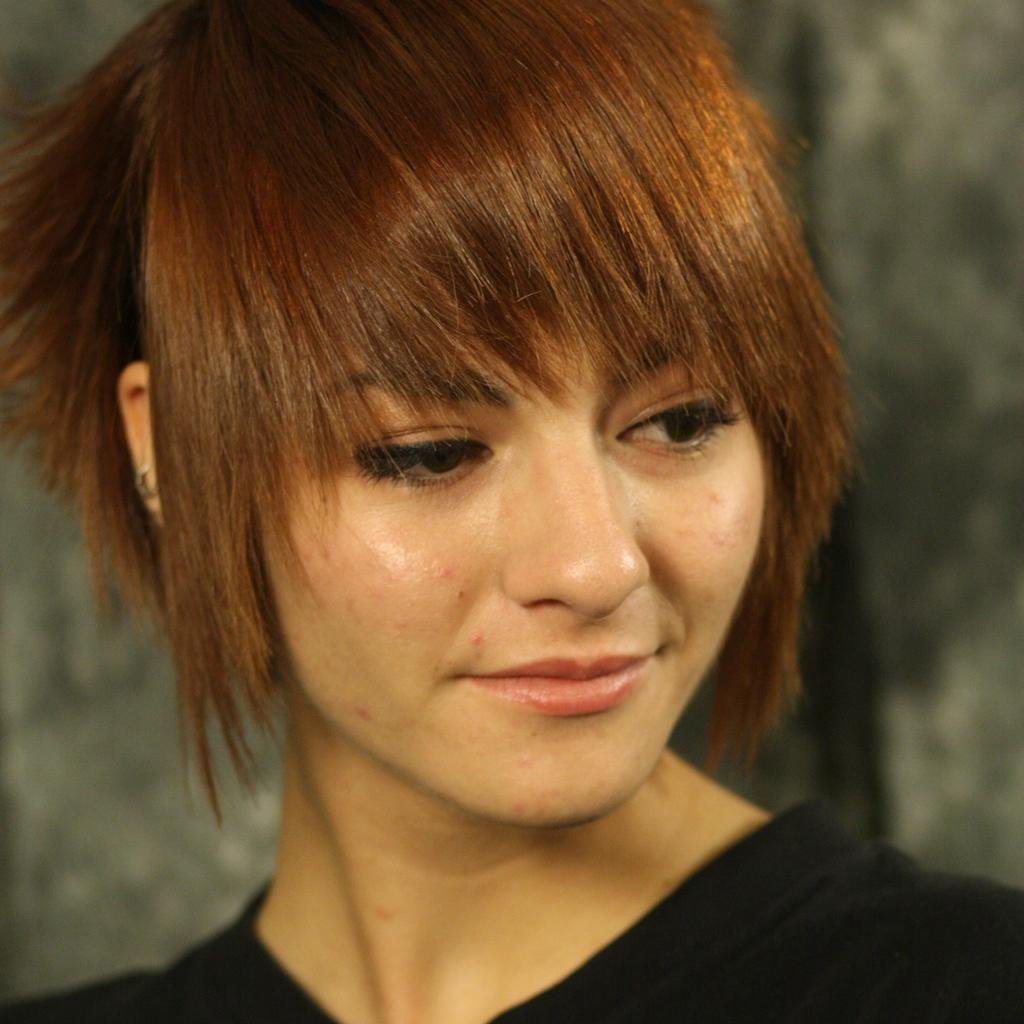Who is the main subject in the image? There is a woman in the image. Can you describe the background of the image? The background of the image is blurred. What type of punishment is the woman receiving in the image? There is no indication of punishment in the image; it only features a woman with a blurred background. 